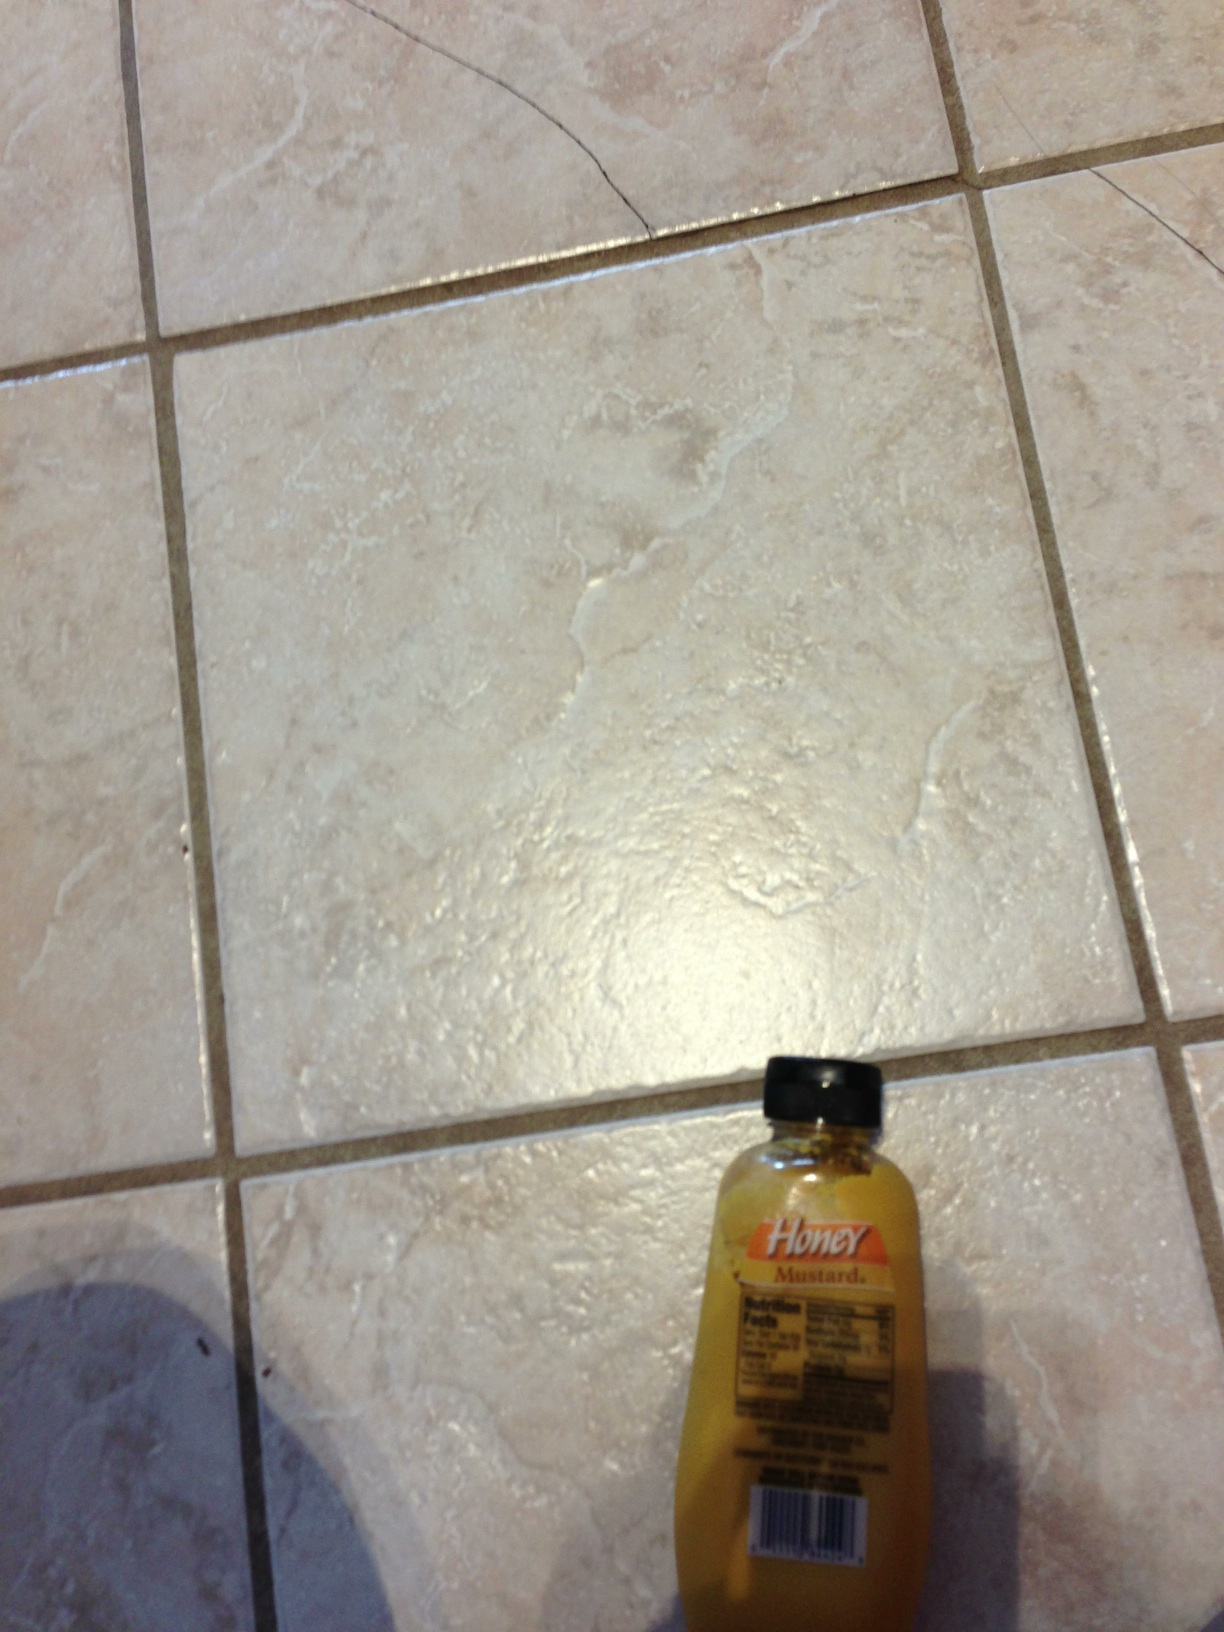What is this? This is a bottle of honey mustard salad dressing. Honey mustard is a delicious condiment made from mustard and honey, providing a sweet and tangy flavor to various dishes. 